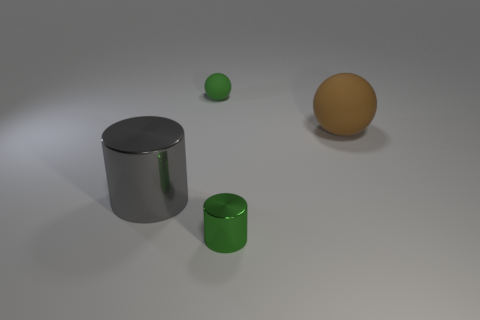Add 3 big gray cylinders. How many objects exist? 7 Add 2 big red metallic things. How many big red metallic things exist? 2 Subtract 0 yellow balls. How many objects are left? 4 Subtract all matte things. Subtract all small rubber things. How many objects are left? 1 Add 4 large brown balls. How many large brown balls are left? 5 